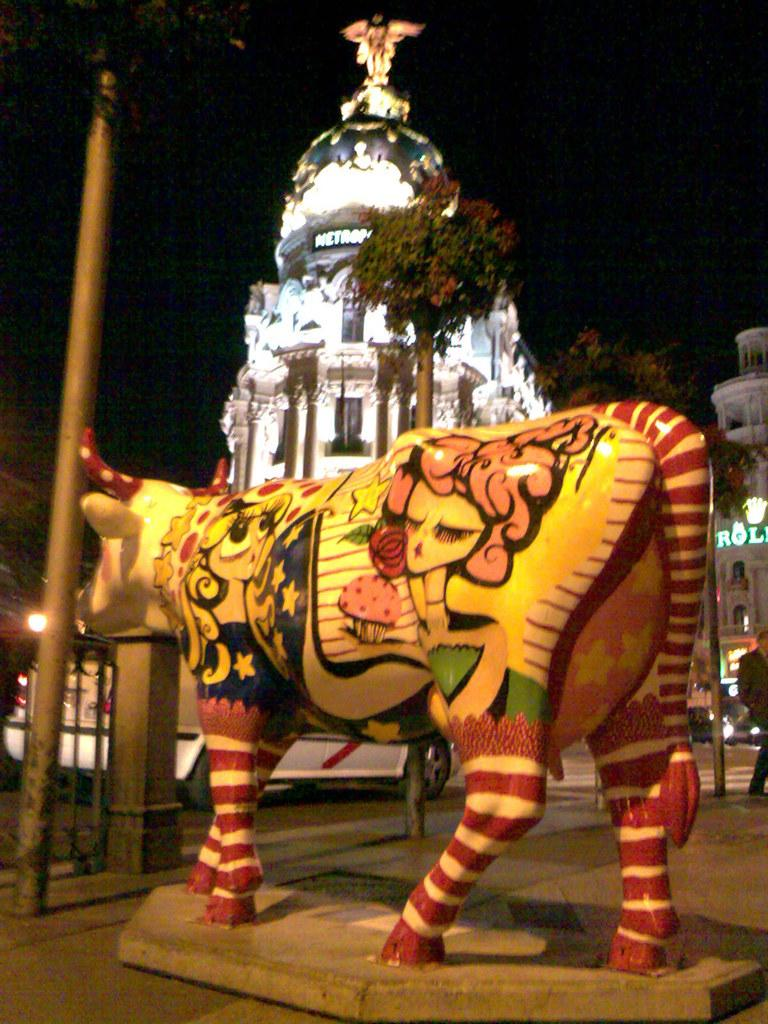What type of object is the main subject in the image? There is a colorful animal statue in the image. What else can be seen in the image besides the statue? There is a pole in the image. What can be seen in the background of the image? There are trees and buildings in the background of the image. Where is the person located in the image? The person is on the left side of the image. How many jellyfish are swimming around the statue in the image? There are no jellyfish present in the image; it features a colorful animal statue, a pole, trees, buildings, and a person. What shape is the memory depicted in the image? There is no memory depicted in the image; it is a photograph of a statue, a pole, trees, buildings, and a person. 